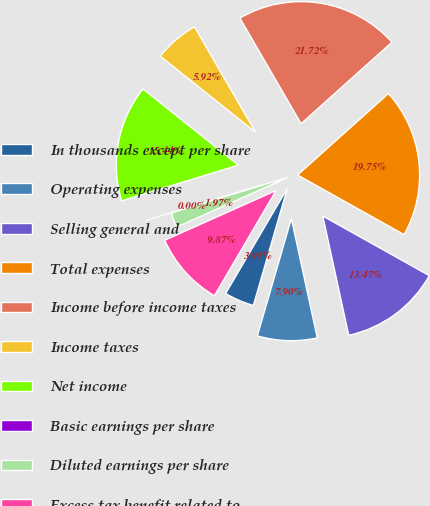<chart> <loc_0><loc_0><loc_500><loc_500><pie_chart><fcel>In thousands except per share<fcel>Operating expenses<fcel>Selling general and<fcel>Total expenses<fcel>Income before income taxes<fcel>Income taxes<fcel>Net income<fcel>Basic earnings per share<fcel>Diluted earnings per share<fcel>Excess tax benefit related to<nl><fcel>3.95%<fcel>7.9%<fcel>13.47%<fcel>19.75%<fcel>21.72%<fcel>5.92%<fcel>15.44%<fcel>0.0%<fcel>1.97%<fcel>9.87%<nl></chart> 